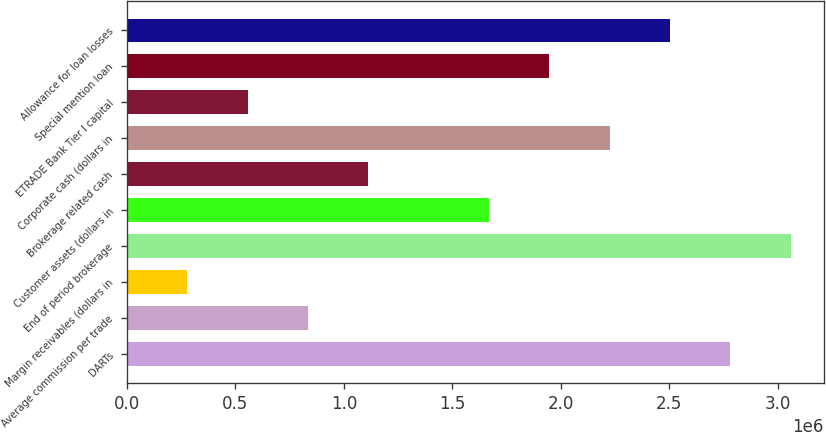<chart> <loc_0><loc_0><loc_500><loc_500><bar_chart><fcel>DARTs<fcel>Average commission per trade<fcel>Margin receivables (dollars in<fcel>End of period brokerage<fcel>Customer assets (dollars in<fcel>Brokerage related cash<fcel>Corporate cash (dollars in<fcel>ETRADE Bank Tier I capital<fcel>Special mention loan<fcel>Allowance for loan losses<nl><fcel>2.78301e+06<fcel>834906<fcel>278304<fcel>3.06131e+06<fcel>1.66981e+06<fcel>1.11321e+06<fcel>2.22641e+06<fcel>556605<fcel>1.94811e+06<fcel>2.50471e+06<nl></chart> 